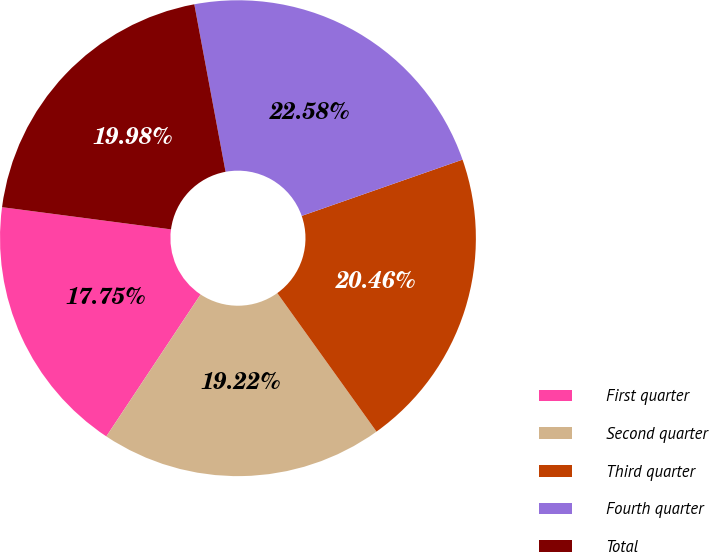Convert chart. <chart><loc_0><loc_0><loc_500><loc_500><pie_chart><fcel>First quarter<fcel>Second quarter<fcel>Third quarter<fcel>Fourth quarter<fcel>Total<nl><fcel>17.75%<fcel>19.22%<fcel>20.46%<fcel>22.58%<fcel>19.98%<nl></chart> 